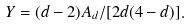Convert formula to latex. <formula><loc_0><loc_0><loc_500><loc_500>Y = ( d - 2 ) A _ { d } / [ 2 d ( 4 - d ) ] .</formula> 